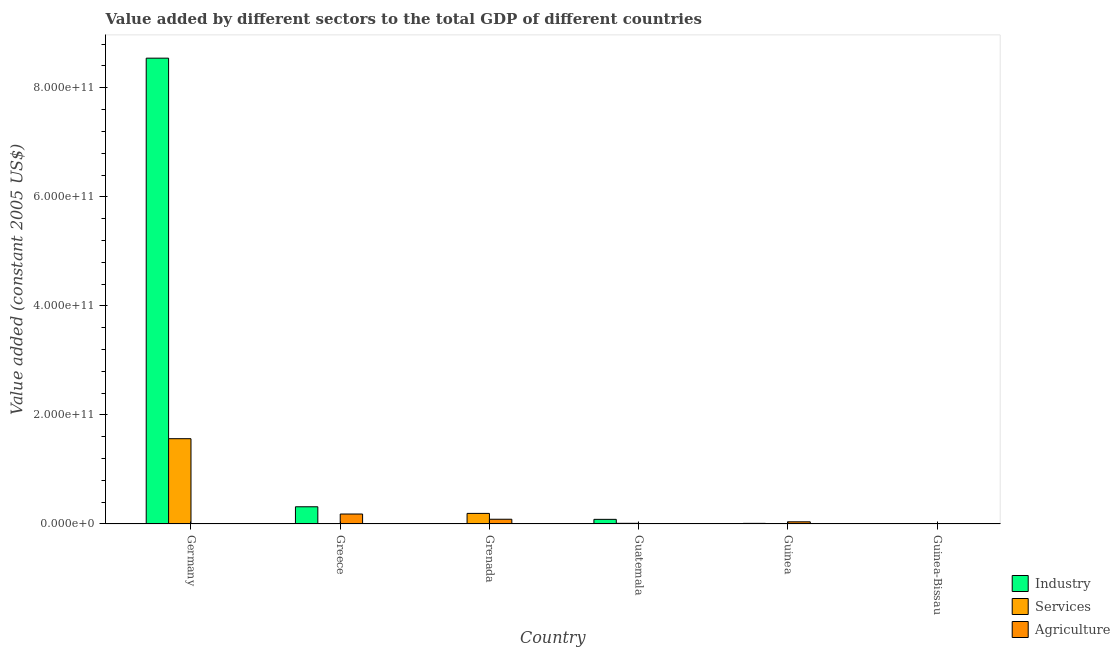How many different coloured bars are there?
Your answer should be compact. 3. Are the number of bars per tick equal to the number of legend labels?
Provide a succinct answer. Yes. Are the number of bars on each tick of the X-axis equal?
Make the answer very short. Yes. What is the label of the 2nd group of bars from the left?
Provide a short and direct response. Greece. What is the value added by industrial sector in Grenada?
Give a very brief answer. 8.81e+07. Across all countries, what is the maximum value added by services?
Your answer should be very brief. 1.56e+11. Across all countries, what is the minimum value added by industrial sector?
Provide a short and direct response. 8.81e+07. In which country was the value added by industrial sector minimum?
Your response must be concise. Grenada. What is the total value added by services in the graph?
Provide a succinct answer. 1.78e+11. What is the difference between the value added by industrial sector in Greece and that in Guinea-Bissau?
Ensure brevity in your answer.  3.15e+1. What is the difference between the value added by agricultural sector in Guinea-Bissau and the value added by industrial sector in Guatemala?
Give a very brief answer. -7.67e+09. What is the average value added by services per country?
Offer a terse response. 2.97e+1. What is the difference between the value added by services and value added by agricultural sector in Germany?
Keep it short and to the point. 1.56e+11. In how many countries, is the value added by agricultural sector greater than 600000000000 US$?
Provide a short and direct response. 0. What is the ratio of the value added by agricultural sector in Greece to that in Grenada?
Keep it short and to the point. 2.1. Is the value added by services in Grenada less than that in Guatemala?
Offer a terse response. No. Is the difference between the value added by agricultural sector in Germany and Guinea-Bissau greater than the difference between the value added by services in Germany and Guinea-Bissau?
Keep it short and to the point. No. What is the difference between the highest and the second highest value added by industrial sector?
Offer a very short reply. 8.23e+11. What is the difference between the highest and the lowest value added by agricultural sector?
Your response must be concise. 1.82e+1. In how many countries, is the value added by industrial sector greater than the average value added by industrial sector taken over all countries?
Keep it short and to the point. 1. What does the 2nd bar from the left in Grenada represents?
Ensure brevity in your answer.  Services. What does the 3rd bar from the right in Greece represents?
Your answer should be very brief. Industry. Is it the case that in every country, the sum of the value added by industrial sector and value added by services is greater than the value added by agricultural sector?
Make the answer very short. No. How many bars are there?
Keep it short and to the point. 18. Are all the bars in the graph horizontal?
Your response must be concise. No. How many countries are there in the graph?
Keep it short and to the point. 6. What is the difference between two consecutive major ticks on the Y-axis?
Provide a short and direct response. 2.00e+11. Are the values on the major ticks of Y-axis written in scientific E-notation?
Provide a succinct answer. Yes. Does the graph contain grids?
Ensure brevity in your answer.  No. Where does the legend appear in the graph?
Ensure brevity in your answer.  Bottom right. How are the legend labels stacked?
Your answer should be very brief. Vertical. What is the title of the graph?
Offer a terse response. Value added by different sectors to the total GDP of different countries. Does "Domestic economy" appear as one of the legend labels in the graph?
Your response must be concise. No. What is the label or title of the X-axis?
Your answer should be compact. Country. What is the label or title of the Y-axis?
Keep it short and to the point. Value added (constant 2005 US$). What is the Value added (constant 2005 US$) in Industry in Germany?
Provide a short and direct response. 8.54e+11. What is the Value added (constant 2005 US$) of Services in Germany?
Your response must be concise. 1.56e+11. What is the Value added (constant 2005 US$) of Agriculture in Germany?
Your answer should be very brief. 8.73e+08. What is the Value added (constant 2005 US$) in Industry in Greece?
Your answer should be compact. 3.16e+1. What is the Value added (constant 2005 US$) in Services in Greece?
Offer a very short reply. 4.59e+08. What is the Value added (constant 2005 US$) in Agriculture in Greece?
Offer a very short reply. 1.83e+1. What is the Value added (constant 2005 US$) in Industry in Grenada?
Offer a terse response. 8.81e+07. What is the Value added (constant 2005 US$) in Services in Grenada?
Your answer should be compact. 1.94e+1. What is the Value added (constant 2005 US$) of Agriculture in Grenada?
Give a very brief answer. 8.68e+09. What is the Value added (constant 2005 US$) in Industry in Guatemala?
Offer a very short reply. 8.48e+09. What is the Value added (constant 2005 US$) of Services in Guatemala?
Your answer should be compact. 1.22e+09. What is the Value added (constant 2005 US$) of Agriculture in Guatemala?
Give a very brief answer. 3.09e+07. What is the Value added (constant 2005 US$) of Industry in Guinea?
Your response must be concise. 1.11e+09. What is the Value added (constant 2005 US$) in Services in Guinea?
Provide a succinct answer. 3.03e+08. What is the Value added (constant 2005 US$) of Agriculture in Guinea?
Ensure brevity in your answer.  3.97e+09. What is the Value added (constant 2005 US$) of Industry in Guinea-Bissau?
Your answer should be compact. 9.24e+07. What is the Value added (constant 2005 US$) in Services in Guinea-Bissau?
Give a very brief answer. 4.58e+08. What is the Value added (constant 2005 US$) of Agriculture in Guinea-Bissau?
Keep it short and to the point. 8.07e+08. Across all countries, what is the maximum Value added (constant 2005 US$) in Industry?
Ensure brevity in your answer.  8.54e+11. Across all countries, what is the maximum Value added (constant 2005 US$) of Services?
Your answer should be compact. 1.56e+11. Across all countries, what is the maximum Value added (constant 2005 US$) of Agriculture?
Give a very brief answer. 1.83e+1. Across all countries, what is the minimum Value added (constant 2005 US$) of Industry?
Provide a short and direct response. 8.81e+07. Across all countries, what is the minimum Value added (constant 2005 US$) in Services?
Ensure brevity in your answer.  3.03e+08. Across all countries, what is the minimum Value added (constant 2005 US$) in Agriculture?
Keep it short and to the point. 3.09e+07. What is the total Value added (constant 2005 US$) in Industry in the graph?
Your answer should be very brief. 8.96e+11. What is the total Value added (constant 2005 US$) in Services in the graph?
Offer a very short reply. 1.78e+11. What is the total Value added (constant 2005 US$) in Agriculture in the graph?
Make the answer very short. 3.26e+1. What is the difference between the Value added (constant 2005 US$) in Industry in Germany and that in Greece?
Your answer should be very brief. 8.23e+11. What is the difference between the Value added (constant 2005 US$) of Services in Germany and that in Greece?
Provide a short and direct response. 1.56e+11. What is the difference between the Value added (constant 2005 US$) of Agriculture in Germany and that in Greece?
Make the answer very short. -1.74e+1. What is the difference between the Value added (constant 2005 US$) in Industry in Germany and that in Grenada?
Offer a terse response. 8.54e+11. What is the difference between the Value added (constant 2005 US$) in Services in Germany and that in Grenada?
Offer a terse response. 1.37e+11. What is the difference between the Value added (constant 2005 US$) in Agriculture in Germany and that in Grenada?
Keep it short and to the point. -7.81e+09. What is the difference between the Value added (constant 2005 US$) of Industry in Germany and that in Guatemala?
Your answer should be very brief. 8.46e+11. What is the difference between the Value added (constant 2005 US$) in Services in Germany and that in Guatemala?
Provide a short and direct response. 1.55e+11. What is the difference between the Value added (constant 2005 US$) in Agriculture in Germany and that in Guatemala?
Keep it short and to the point. 8.42e+08. What is the difference between the Value added (constant 2005 US$) in Industry in Germany and that in Guinea?
Provide a short and direct response. 8.53e+11. What is the difference between the Value added (constant 2005 US$) of Services in Germany and that in Guinea?
Make the answer very short. 1.56e+11. What is the difference between the Value added (constant 2005 US$) of Agriculture in Germany and that in Guinea?
Provide a short and direct response. -3.09e+09. What is the difference between the Value added (constant 2005 US$) of Industry in Germany and that in Guinea-Bissau?
Your response must be concise. 8.54e+11. What is the difference between the Value added (constant 2005 US$) of Services in Germany and that in Guinea-Bissau?
Ensure brevity in your answer.  1.56e+11. What is the difference between the Value added (constant 2005 US$) in Agriculture in Germany and that in Guinea-Bissau?
Provide a succinct answer. 6.59e+07. What is the difference between the Value added (constant 2005 US$) in Industry in Greece and that in Grenada?
Your response must be concise. 3.15e+1. What is the difference between the Value added (constant 2005 US$) of Services in Greece and that in Grenada?
Offer a terse response. -1.89e+1. What is the difference between the Value added (constant 2005 US$) of Agriculture in Greece and that in Grenada?
Make the answer very short. 9.59e+09. What is the difference between the Value added (constant 2005 US$) in Industry in Greece and that in Guatemala?
Your answer should be compact. 2.31e+1. What is the difference between the Value added (constant 2005 US$) in Services in Greece and that in Guatemala?
Provide a succinct answer. -7.63e+08. What is the difference between the Value added (constant 2005 US$) in Agriculture in Greece and that in Guatemala?
Your answer should be compact. 1.82e+1. What is the difference between the Value added (constant 2005 US$) in Industry in Greece and that in Guinea?
Provide a succinct answer. 3.04e+1. What is the difference between the Value added (constant 2005 US$) of Services in Greece and that in Guinea?
Provide a succinct answer. 1.56e+08. What is the difference between the Value added (constant 2005 US$) of Agriculture in Greece and that in Guinea?
Provide a succinct answer. 1.43e+1. What is the difference between the Value added (constant 2005 US$) in Industry in Greece and that in Guinea-Bissau?
Provide a short and direct response. 3.15e+1. What is the difference between the Value added (constant 2005 US$) of Services in Greece and that in Guinea-Bissau?
Provide a short and direct response. 6.41e+05. What is the difference between the Value added (constant 2005 US$) of Agriculture in Greece and that in Guinea-Bissau?
Provide a succinct answer. 1.75e+1. What is the difference between the Value added (constant 2005 US$) of Industry in Grenada and that in Guatemala?
Offer a very short reply. -8.39e+09. What is the difference between the Value added (constant 2005 US$) of Services in Grenada and that in Guatemala?
Offer a very short reply. 1.82e+1. What is the difference between the Value added (constant 2005 US$) in Agriculture in Grenada and that in Guatemala?
Provide a succinct answer. 8.65e+09. What is the difference between the Value added (constant 2005 US$) of Industry in Grenada and that in Guinea?
Offer a terse response. -1.02e+09. What is the difference between the Value added (constant 2005 US$) in Services in Grenada and that in Guinea?
Your answer should be very brief. 1.91e+1. What is the difference between the Value added (constant 2005 US$) of Agriculture in Grenada and that in Guinea?
Your response must be concise. 4.71e+09. What is the difference between the Value added (constant 2005 US$) in Industry in Grenada and that in Guinea-Bissau?
Your response must be concise. -4.35e+06. What is the difference between the Value added (constant 2005 US$) of Services in Grenada and that in Guinea-Bissau?
Your answer should be very brief. 1.89e+1. What is the difference between the Value added (constant 2005 US$) in Agriculture in Grenada and that in Guinea-Bissau?
Your response must be concise. 7.87e+09. What is the difference between the Value added (constant 2005 US$) of Industry in Guatemala and that in Guinea?
Keep it short and to the point. 7.37e+09. What is the difference between the Value added (constant 2005 US$) of Services in Guatemala and that in Guinea?
Your answer should be compact. 9.19e+08. What is the difference between the Value added (constant 2005 US$) of Agriculture in Guatemala and that in Guinea?
Make the answer very short. -3.94e+09. What is the difference between the Value added (constant 2005 US$) in Industry in Guatemala and that in Guinea-Bissau?
Ensure brevity in your answer.  8.39e+09. What is the difference between the Value added (constant 2005 US$) of Services in Guatemala and that in Guinea-Bissau?
Give a very brief answer. 7.64e+08. What is the difference between the Value added (constant 2005 US$) of Agriculture in Guatemala and that in Guinea-Bissau?
Give a very brief answer. -7.76e+08. What is the difference between the Value added (constant 2005 US$) of Industry in Guinea and that in Guinea-Bissau?
Your answer should be very brief. 1.02e+09. What is the difference between the Value added (constant 2005 US$) in Services in Guinea and that in Guinea-Bissau?
Give a very brief answer. -1.55e+08. What is the difference between the Value added (constant 2005 US$) in Agriculture in Guinea and that in Guinea-Bissau?
Ensure brevity in your answer.  3.16e+09. What is the difference between the Value added (constant 2005 US$) in Industry in Germany and the Value added (constant 2005 US$) in Services in Greece?
Provide a succinct answer. 8.54e+11. What is the difference between the Value added (constant 2005 US$) of Industry in Germany and the Value added (constant 2005 US$) of Agriculture in Greece?
Your answer should be very brief. 8.36e+11. What is the difference between the Value added (constant 2005 US$) in Services in Germany and the Value added (constant 2005 US$) in Agriculture in Greece?
Provide a succinct answer. 1.38e+11. What is the difference between the Value added (constant 2005 US$) of Industry in Germany and the Value added (constant 2005 US$) of Services in Grenada?
Make the answer very short. 8.35e+11. What is the difference between the Value added (constant 2005 US$) of Industry in Germany and the Value added (constant 2005 US$) of Agriculture in Grenada?
Provide a short and direct response. 8.46e+11. What is the difference between the Value added (constant 2005 US$) of Services in Germany and the Value added (constant 2005 US$) of Agriculture in Grenada?
Your answer should be very brief. 1.48e+11. What is the difference between the Value added (constant 2005 US$) of Industry in Germany and the Value added (constant 2005 US$) of Services in Guatemala?
Offer a very short reply. 8.53e+11. What is the difference between the Value added (constant 2005 US$) of Industry in Germany and the Value added (constant 2005 US$) of Agriculture in Guatemala?
Provide a short and direct response. 8.54e+11. What is the difference between the Value added (constant 2005 US$) of Services in Germany and the Value added (constant 2005 US$) of Agriculture in Guatemala?
Make the answer very short. 1.56e+11. What is the difference between the Value added (constant 2005 US$) in Industry in Germany and the Value added (constant 2005 US$) in Services in Guinea?
Offer a very short reply. 8.54e+11. What is the difference between the Value added (constant 2005 US$) in Industry in Germany and the Value added (constant 2005 US$) in Agriculture in Guinea?
Provide a short and direct response. 8.50e+11. What is the difference between the Value added (constant 2005 US$) in Services in Germany and the Value added (constant 2005 US$) in Agriculture in Guinea?
Give a very brief answer. 1.52e+11. What is the difference between the Value added (constant 2005 US$) of Industry in Germany and the Value added (constant 2005 US$) of Services in Guinea-Bissau?
Provide a succinct answer. 8.54e+11. What is the difference between the Value added (constant 2005 US$) of Industry in Germany and the Value added (constant 2005 US$) of Agriculture in Guinea-Bissau?
Keep it short and to the point. 8.54e+11. What is the difference between the Value added (constant 2005 US$) of Services in Germany and the Value added (constant 2005 US$) of Agriculture in Guinea-Bissau?
Give a very brief answer. 1.56e+11. What is the difference between the Value added (constant 2005 US$) in Industry in Greece and the Value added (constant 2005 US$) in Services in Grenada?
Offer a terse response. 1.22e+1. What is the difference between the Value added (constant 2005 US$) of Industry in Greece and the Value added (constant 2005 US$) of Agriculture in Grenada?
Keep it short and to the point. 2.29e+1. What is the difference between the Value added (constant 2005 US$) in Services in Greece and the Value added (constant 2005 US$) in Agriculture in Grenada?
Give a very brief answer. -8.22e+09. What is the difference between the Value added (constant 2005 US$) of Industry in Greece and the Value added (constant 2005 US$) of Services in Guatemala?
Your answer should be very brief. 3.03e+1. What is the difference between the Value added (constant 2005 US$) of Industry in Greece and the Value added (constant 2005 US$) of Agriculture in Guatemala?
Provide a succinct answer. 3.15e+1. What is the difference between the Value added (constant 2005 US$) in Services in Greece and the Value added (constant 2005 US$) in Agriculture in Guatemala?
Your answer should be compact. 4.28e+08. What is the difference between the Value added (constant 2005 US$) of Industry in Greece and the Value added (constant 2005 US$) of Services in Guinea?
Give a very brief answer. 3.13e+1. What is the difference between the Value added (constant 2005 US$) of Industry in Greece and the Value added (constant 2005 US$) of Agriculture in Guinea?
Your response must be concise. 2.76e+1. What is the difference between the Value added (constant 2005 US$) of Services in Greece and the Value added (constant 2005 US$) of Agriculture in Guinea?
Your answer should be compact. -3.51e+09. What is the difference between the Value added (constant 2005 US$) in Industry in Greece and the Value added (constant 2005 US$) in Services in Guinea-Bissau?
Make the answer very short. 3.11e+1. What is the difference between the Value added (constant 2005 US$) of Industry in Greece and the Value added (constant 2005 US$) of Agriculture in Guinea-Bissau?
Keep it short and to the point. 3.08e+1. What is the difference between the Value added (constant 2005 US$) of Services in Greece and the Value added (constant 2005 US$) of Agriculture in Guinea-Bissau?
Provide a short and direct response. -3.48e+08. What is the difference between the Value added (constant 2005 US$) in Industry in Grenada and the Value added (constant 2005 US$) in Services in Guatemala?
Give a very brief answer. -1.13e+09. What is the difference between the Value added (constant 2005 US$) of Industry in Grenada and the Value added (constant 2005 US$) of Agriculture in Guatemala?
Provide a short and direct response. 5.71e+07. What is the difference between the Value added (constant 2005 US$) in Services in Grenada and the Value added (constant 2005 US$) in Agriculture in Guatemala?
Make the answer very short. 1.94e+1. What is the difference between the Value added (constant 2005 US$) of Industry in Grenada and the Value added (constant 2005 US$) of Services in Guinea?
Provide a succinct answer. -2.15e+08. What is the difference between the Value added (constant 2005 US$) of Industry in Grenada and the Value added (constant 2005 US$) of Agriculture in Guinea?
Ensure brevity in your answer.  -3.88e+09. What is the difference between the Value added (constant 2005 US$) in Services in Grenada and the Value added (constant 2005 US$) in Agriculture in Guinea?
Your response must be concise. 1.54e+1. What is the difference between the Value added (constant 2005 US$) in Industry in Grenada and the Value added (constant 2005 US$) in Services in Guinea-Bissau?
Offer a very short reply. -3.70e+08. What is the difference between the Value added (constant 2005 US$) of Industry in Grenada and the Value added (constant 2005 US$) of Agriculture in Guinea-Bissau?
Give a very brief answer. -7.19e+08. What is the difference between the Value added (constant 2005 US$) of Services in Grenada and the Value added (constant 2005 US$) of Agriculture in Guinea-Bissau?
Ensure brevity in your answer.  1.86e+1. What is the difference between the Value added (constant 2005 US$) in Industry in Guatemala and the Value added (constant 2005 US$) in Services in Guinea?
Offer a very short reply. 8.18e+09. What is the difference between the Value added (constant 2005 US$) in Industry in Guatemala and the Value added (constant 2005 US$) in Agriculture in Guinea?
Your answer should be compact. 4.51e+09. What is the difference between the Value added (constant 2005 US$) of Services in Guatemala and the Value added (constant 2005 US$) of Agriculture in Guinea?
Your response must be concise. -2.74e+09. What is the difference between the Value added (constant 2005 US$) in Industry in Guatemala and the Value added (constant 2005 US$) in Services in Guinea-Bissau?
Provide a succinct answer. 8.02e+09. What is the difference between the Value added (constant 2005 US$) in Industry in Guatemala and the Value added (constant 2005 US$) in Agriculture in Guinea-Bissau?
Keep it short and to the point. 7.67e+09. What is the difference between the Value added (constant 2005 US$) of Services in Guatemala and the Value added (constant 2005 US$) of Agriculture in Guinea-Bissau?
Your answer should be compact. 4.15e+08. What is the difference between the Value added (constant 2005 US$) in Industry in Guinea and the Value added (constant 2005 US$) in Services in Guinea-Bissau?
Offer a terse response. 6.51e+08. What is the difference between the Value added (constant 2005 US$) in Industry in Guinea and the Value added (constant 2005 US$) in Agriculture in Guinea-Bissau?
Give a very brief answer. 3.02e+08. What is the difference between the Value added (constant 2005 US$) in Services in Guinea and the Value added (constant 2005 US$) in Agriculture in Guinea-Bissau?
Your answer should be compact. -5.04e+08. What is the average Value added (constant 2005 US$) in Industry per country?
Provide a short and direct response. 1.49e+11. What is the average Value added (constant 2005 US$) in Services per country?
Offer a very short reply. 2.97e+1. What is the average Value added (constant 2005 US$) in Agriculture per country?
Offer a terse response. 5.44e+09. What is the difference between the Value added (constant 2005 US$) in Industry and Value added (constant 2005 US$) in Services in Germany?
Ensure brevity in your answer.  6.98e+11. What is the difference between the Value added (constant 2005 US$) of Industry and Value added (constant 2005 US$) of Agriculture in Germany?
Your response must be concise. 8.53e+11. What is the difference between the Value added (constant 2005 US$) of Services and Value added (constant 2005 US$) of Agriculture in Germany?
Your answer should be very brief. 1.56e+11. What is the difference between the Value added (constant 2005 US$) of Industry and Value added (constant 2005 US$) of Services in Greece?
Offer a terse response. 3.11e+1. What is the difference between the Value added (constant 2005 US$) in Industry and Value added (constant 2005 US$) in Agriculture in Greece?
Your answer should be compact. 1.33e+1. What is the difference between the Value added (constant 2005 US$) of Services and Value added (constant 2005 US$) of Agriculture in Greece?
Offer a terse response. -1.78e+1. What is the difference between the Value added (constant 2005 US$) of Industry and Value added (constant 2005 US$) of Services in Grenada?
Keep it short and to the point. -1.93e+1. What is the difference between the Value added (constant 2005 US$) in Industry and Value added (constant 2005 US$) in Agriculture in Grenada?
Keep it short and to the point. -8.59e+09. What is the difference between the Value added (constant 2005 US$) of Services and Value added (constant 2005 US$) of Agriculture in Grenada?
Keep it short and to the point. 1.07e+1. What is the difference between the Value added (constant 2005 US$) in Industry and Value added (constant 2005 US$) in Services in Guatemala?
Offer a very short reply. 7.26e+09. What is the difference between the Value added (constant 2005 US$) of Industry and Value added (constant 2005 US$) of Agriculture in Guatemala?
Your answer should be very brief. 8.45e+09. What is the difference between the Value added (constant 2005 US$) of Services and Value added (constant 2005 US$) of Agriculture in Guatemala?
Ensure brevity in your answer.  1.19e+09. What is the difference between the Value added (constant 2005 US$) of Industry and Value added (constant 2005 US$) of Services in Guinea?
Offer a terse response. 8.06e+08. What is the difference between the Value added (constant 2005 US$) of Industry and Value added (constant 2005 US$) of Agriculture in Guinea?
Give a very brief answer. -2.86e+09. What is the difference between the Value added (constant 2005 US$) in Services and Value added (constant 2005 US$) in Agriculture in Guinea?
Provide a succinct answer. -3.66e+09. What is the difference between the Value added (constant 2005 US$) of Industry and Value added (constant 2005 US$) of Services in Guinea-Bissau?
Provide a succinct answer. -3.66e+08. What is the difference between the Value added (constant 2005 US$) of Industry and Value added (constant 2005 US$) of Agriculture in Guinea-Bissau?
Give a very brief answer. -7.15e+08. What is the difference between the Value added (constant 2005 US$) of Services and Value added (constant 2005 US$) of Agriculture in Guinea-Bissau?
Give a very brief answer. -3.49e+08. What is the ratio of the Value added (constant 2005 US$) of Industry in Germany to that in Greece?
Offer a very short reply. 27.07. What is the ratio of the Value added (constant 2005 US$) of Services in Germany to that in Greece?
Provide a succinct answer. 340.78. What is the ratio of the Value added (constant 2005 US$) of Agriculture in Germany to that in Greece?
Your answer should be very brief. 0.05. What is the ratio of the Value added (constant 2005 US$) of Industry in Germany to that in Grenada?
Your answer should be very brief. 9702.16. What is the ratio of the Value added (constant 2005 US$) of Services in Germany to that in Grenada?
Give a very brief answer. 8.07. What is the ratio of the Value added (constant 2005 US$) in Agriculture in Germany to that in Grenada?
Make the answer very short. 0.1. What is the ratio of the Value added (constant 2005 US$) in Industry in Germany to that in Guatemala?
Make the answer very short. 100.75. What is the ratio of the Value added (constant 2005 US$) in Services in Germany to that in Guatemala?
Offer a terse response. 128.01. What is the ratio of the Value added (constant 2005 US$) of Agriculture in Germany to that in Guatemala?
Your answer should be compact. 28.22. What is the ratio of the Value added (constant 2005 US$) of Industry in Germany to that in Guinea?
Provide a succinct answer. 770.15. What is the ratio of the Value added (constant 2005 US$) in Services in Germany to that in Guinea?
Your answer should be compact. 516.17. What is the ratio of the Value added (constant 2005 US$) of Agriculture in Germany to that in Guinea?
Offer a terse response. 0.22. What is the ratio of the Value added (constant 2005 US$) in Industry in Germany to that in Guinea-Bissau?
Ensure brevity in your answer.  9245.66. What is the ratio of the Value added (constant 2005 US$) in Services in Germany to that in Guinea-Bissau?
Offer a terse response. 341.26. What is the ratio of the Value added (constant 2005 US$) of Agriculture in Germany to that in Guinea-Bissau?
Ensure brevity in your answer.  1.08. What is the ratio of the Value added (constant 2005 US$) in Industry in Greece to that in Grenada?
Provide a short and direct response. 358.37. What is the ratio of the Value added (constant 2005 US$) in Services in Greece to that in Grenada?
Ensure brevity in your answer.  0.02. What is the ratio of the Value added (constant 2005 US$) in Agriculture in Greece to that in Grenada?
Keep it short and to the point. 2.1. What is the ratio of the Value added (constant 2005 US$) in Industry in Greece to that in Guatemala?
Offer a terse response. 3.72. What is the ratio of the Value added (constant 2005 US$) in Services in Greece to that in Guatemala?
Your answer should be very brief. 0.38. What is the ratio of the Value added (constant 2005 US$) of Agriculture in Greece to that in Guatemala?
Your response must be concise. 590.38. What is the ratio of the Value added (constant 2005 US$) of Industry in Greece to that in Guinea?
Keep it short and to the point. 28.45. What is the ratio of the Value added (constant 2005 US$) in Services in Greece to that in Guinea?
Keep it short and to the point. 1.51. What is the ratio of the Value added (constant 2005 US$) of Agriculture in Greece to that in Guinea?
Give a very brief answer. 4.61. What is the ratio of the Value added (constant 2005 US$) in Industry in Greece to that in Guinea-Bissau?
Provide a succinct answer. 341.51. What is the ratio of the Value added (constant 2005 US$) in Services in Greece to that in Guinea-Bissau?
Your answer should be very brief. 1. What is the ratio of the Value added (constant 2005 US$) in Agriculture in Greece to that in Guinea-Bissau?
Ensure brevity in your answer.  22.62. What is the ratio of the Value added (constant 2005 US$) in Industry in Grenada to that in Guatemala?
Your answer should be very brief. 0.01. What is the ratio of the Value added (constant 2005 US$) of Services in Grenada to that in Guatemala?
Offer a very short reply. 15.87. What is the ratio of the Value added (constant 2005 US$) of Agriculture in Grenada to that in Guatemala?
Your answer should be compact. 280.57. What is the ratio of the Value added (constant 2005 US$) of Industry in Grenada to that in Guinea?
Make the answer very short. 0.08. What is the ratio of the Value added (constant 2005 US$) in Services in Grenada to that in Guinea?
Your response must be concise. 64. What is the ratio of the Value added (constant 2005 US$) in Agriculture in Grenada to that in Guinea?
Provide a short and direct response. 2.19. What is the ratio of the Value added (constant 2005 US$) of Industry in Grenada to that in Guinea-Bissau?
Your answer should be very brief. 0.95. What is the ratio of the Value added (constant 2005 US$) in Services in Grenada to that in Guinea-Bissau?
Your answer should be compact. 42.31. What is the ratio of the Value added (constant 2005 US$) in Agriculture in Grenada to that in Guinea-Bissau?
Provide a succinct answer. 10.75. What is the ratio of the Value added (constant 2005 US$) of Industry in Guatemala to that in Guinea?
Your answer should be compact. 7.64. What is the ratio of the Value added (constant 2005 US$) in Services in Guatemala to that in Guinea?
Provide a succinct answer. 4.03. What is the ratio of the Value added (constant 2005 US$) in Agriculture in Guatemala to that in Guinea?
Keep it short and to the point. 0.01. What is the ratio of the Value added (constant 2005 US$) in Industry in Guatemala to that in Guinea-Bissau?
Your response must be concise. 91.77. What is the ratio of the Value added (constant 2005 US$) of Services in Guatemala to that in Guinea-Bissau?
Keep it short and to the point. 2.67. What is the ratio of the Value added (constant 2005 US$) of Agriculture in Guatemala to that in Guinea-Bissau?
Make the answer very short. 0.04. What is the ratio of the Value added (constant 2005 US$) in Industry in Guinea to that in Guinea-Bissau?
Make the answer very short. 12.01. What is the ratio of the Value added (constant 2005 US$) in Services in Guinea to that in Guinea-Bissau?
Offer a terse response. 0.66. What is the ratio of the Value added (constant 2005 US$) in Agriculture in Guinea to that in Guinea-Bissau?
Provide a succinct answer. 4.91. What is the difference between the highest and the second highest Value added (constant 2005 US$) of Industry?
Keep it short and to the point. 8.23e+11. What is the difference between the highest and the second highest Value added (constant 2005 US$) in Services?
Ensure brevity in your answer.  1.37e+11. What is the difference between the highest and the second highest Value added (constant 2005 US$) in Agriculture?
Your response must be concise. 9.59e+09. What is the difference between the highest and the lowest Value added (constant 2005 US$) of Industry?
Provide a succinct answer. 8.54e+11. What is the difference between the highest and the lowest Value added (constant 2005 US$) of Services?
Keep it short and to the point. 1.56e+11. What is the difference between the highest and the lowest Value added (constant 2005 US$) in Agriculture?
Keep it short and to the point. 1.82e+1. 